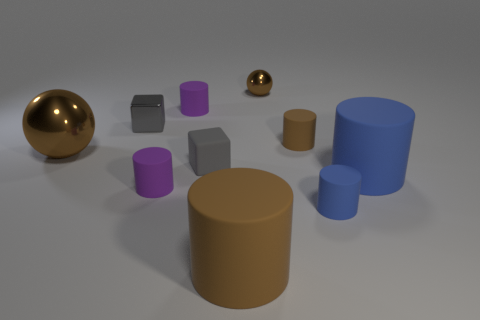Are there an equal number of brown shiny balls that are in front of the large brown metal object and tiny purple rubber objects in front of the small matte cube?
Make the answer very short. No. What number of large brown objects are to the left of the rubber object that is behind the gray object that is behind the big brown shiny thing?
Keep it short and to the point. 1. There is a rubber block; is it the same color as the big rubber cylinder that is on the right side of the large brown matte cylinder?
Your answer should be compact. No. The other sphere that is made of the same material as the big brown ball is what size?
Make the answer very short. Small. Are there more tiny gray rubber cubes that are behind the large sphere than big rubber cylinders?
Provide a succinct answer. No. What material is the tiny brown thing in front of the ball that is on the right side of the sphere that is left of the large brown cylinder?
Keep it short and to the point. Rubber. Do the small blue cylinder and the small block left of the gray matte block have the same material?
Your answer should be very brief. No. There is a small object that is the same shape as the big brown shiny thing; what is its material?
Make the answer very short. Metal. Is there any other thing that is made of the same material as the small blue cylinder?
Keep it short and to the point. Yes. Is the number of brown shiny balls to the right of the small brown matte cylinder greater than the number of brown metallic balls that are in front of the tiny blue rubber cylinder?
Your answer should be very brief. No. 